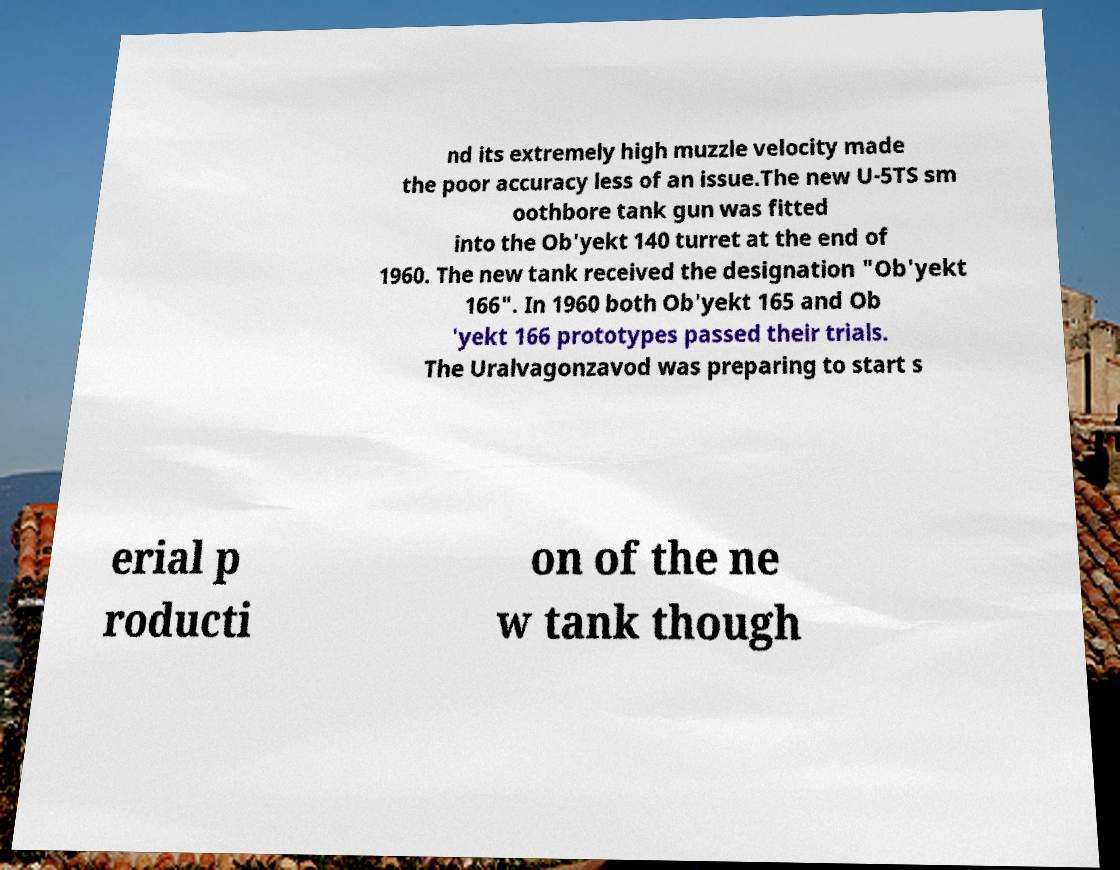What messages or text are displayed in this image? I need them in a readable, typed format. nd its extremely high muzzle velocity made the poor accuracy less of an issue.The new U-5TS sm oothbore tank gun was fitted into the Ob'yekt 140 turret at the end of 1960. The new tank received the designation "Ob'yekt 166". In 1960 both Ob'yekt 165 and Ob 'yekt 166 prototypes passed their trials. The Uralvagonzavod was preparing to start s erial p roducti on of the ne w tank though 